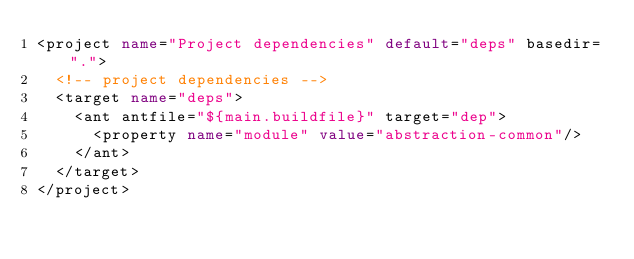<code> <loc_0><loc_0><loc_500><loc_500><_XML_><project name="Project dependencies" default="deps" basedir=".">
	<!-- project dependencies -->
	<target name="deps">
		<ant antfile="${main.buildfile}" target="dep">
			<property name="module" value="abstraction-common"/>
		</ant>
	</target>
</project>
</code> 